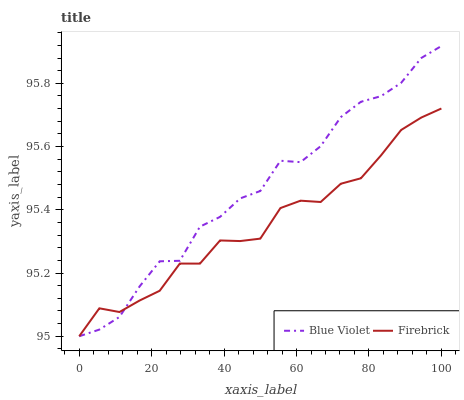Does Firebrick have the minimum area under the curve?
Answer yes or no. Yes. Does Blue Violet have the maximum area under the curve?
Answer yes or no. Yes. Does Blue Violet have the minimum area under the curve?
Answer yes or no. No. Is Firebrick the smoothest?
Answer yes or no. Yes. Is Blue Violet the roughest?
Answer yes or no. Yes. Is Blue Violet the smoothest?
Answer yes or no. No. Does Firebrick have the lowest value?
Answer yes or no. Yes. Does Blue Violet have the highest value?
Answer yes or no. Yes. Does Firebrick intersect Blue Violet?
Answer yes or no. Yes. Is Firebrick less than Blue Violet?
Answer yes or no. No. Is Firebrick greater than Blue Violet?
Answer yes or no. No. 